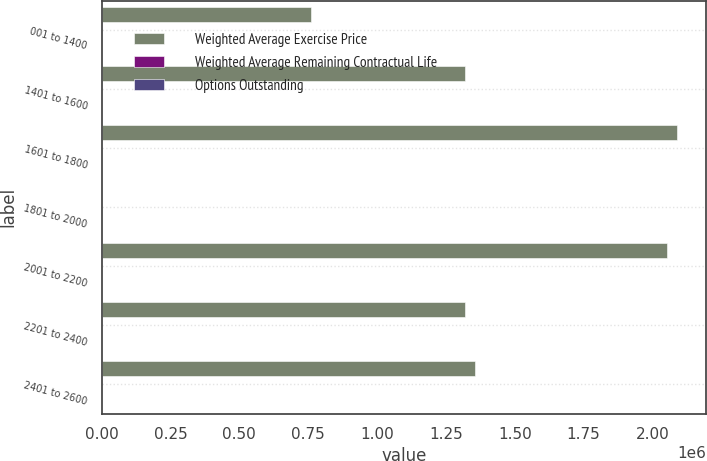Convert chart. <chart><loc_0><loc_0><loc_500><loc_500><stacked_bar_chart><ecel><fcel>001 to 1400<fcel>1401 to 1600<fcel>1601 to 1800<fcel>1801 to 2000<fcel>2001 to 2200<fcel>2201 to 2400<fcel>2401 to 2600<nl><fcel>Weighted Average Exercise Price<fcel>760756<fcel>1.31871e+06<fcel>2.09018e+06<fcel>18.05<fcel>2.05108e+06<fcel>1.31842e+06<fcel>1.35389e+06<nl><fcel>Weighted Average Remaining Contractual Life<fcel>4.13<fcel>2.87<fcel>3.19<fcel>3.94<fcel>6.79<fcel>6.84<fcel>9.05<nl><fcel>Options Outstanding<fcel>13.8<fcel>15.71<fcel>17.34<fcel>18.76<fcel>21.42<fcel>22.93<fcel>24.65<nl></chart> 